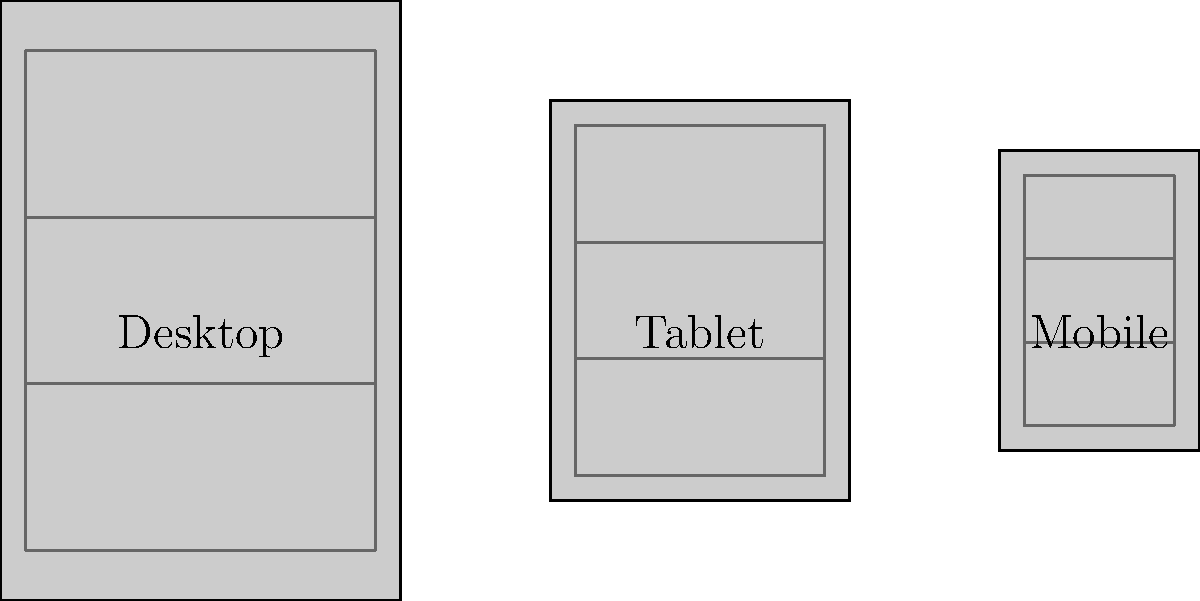In the responsive design layout wireframes shown above, what key principle is being illustrated for adapting content across different device sizes? To answer this question, let's analyze the wireframes step-by-step:

1. We see three device representations: Desktop, Tablet, and Mobile.
2. Each device has a wireframe inside it, representing the content layout.
3. As we move from Desktop to Tablet to Mobile:
   a. The overall size of the device and wireframe decreases.
   b. The aspect ratio of the wireframe changes, becoming more vertical.
   c. The number of horizontal divisions (represented by lines) remains constant at 3.

4. This consistent structure across devices, with adaptations to size and proportion, illustrates the principle of maintaining a coherent layout while adjusting to different screen sizes.

5. The key principle being demonstrated is "Fluid Grid Layout" or "Flexible Layout":
   - Content areas are proportionally sized rather than fixed.
   - The layout adapts to the available screen space while maintaining relative positioning and structure.

6. This approach ensures that the website's main components (likely header, content area, and footer) are present and recognizable across all device sizes, but their dimensions and proportions adjust to fit the screen.
Answer: Fluid Grid Layout 